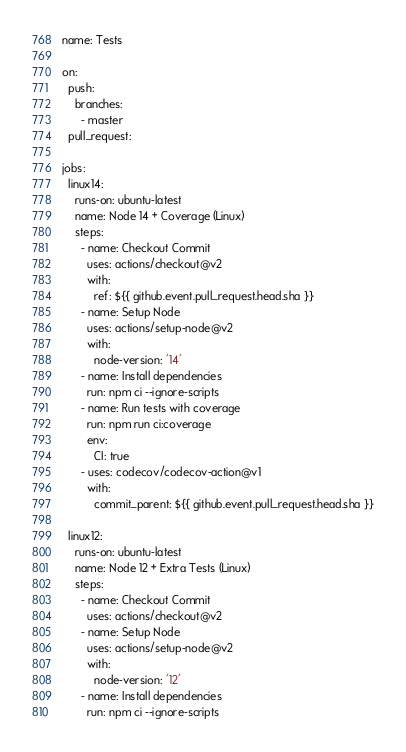Convert code to text. <code><loc_0><loc_0><loc_500><loc_500><_YAML_>name: Tests

on:
  push:
    branches:
      - master
  pull_request:

jobs:
  linux14:
    runs-on: ubuntu-latest
    name: Node 14 + Coverage (Linux)
    steps:
      - name: Checkout Commit
        uses: actions/checkout@v2
        with:
          ref: ${{ github.event.pull_request.head.sha }}
      - name: Setup Node
        uses: actions/setup-node@v2
        with:
          node-version: '14'
      - name: Install dependencies
        run: npm ci --ignore-scripts
      - name: Run tests with coverage
        run: npm run ci:coverage
        env:
          CI: true
      - uses: codecov/codecov-action@v1
        with:
          commit_parent: ${{ github.event.pull_request.head.sha }}

  linux12:
    runs-on: ubuntu-latest
    name: Node 12 + Extra Tests (Linux)
    steps:
      - name: Checkout Commit
        uses: actions/checkout@v2
      - name: Setup Node
        uses: actions/setup-node@v2
        with:
          node-version: '12'
      - name: Install dependencies
        run: npm ci --ignore-scripts</code> 